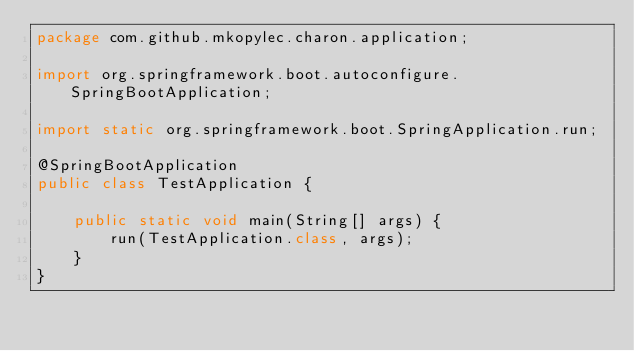Convert code to text. <code><loc_0><loc_0><loc_500><loc_500><_Java_>package com.github.mkopylec.charon.application;

import org.springframework.boot.autoconfigure.SpringBootApplication;

import static org.springframework.boot.SpringApplication.run;

@SpringBootApplication
public class TestApplication {

    public static void main(String[] args) {
        run(TestApplication.class, args);
    }
}
</code> 